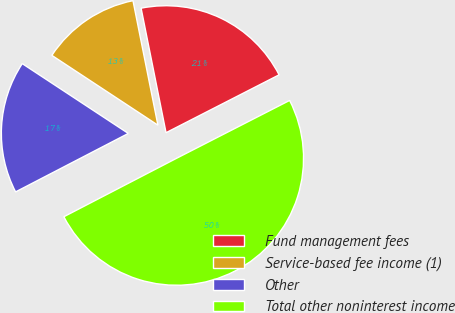Convert chart. <chart><loc_0><loc_0><loc_500><loc_500><pie_chart><fcel>Fund management fees<fcel>Service-based fee income (1)<fcel>Other<fcel>Total other noninterest income<nl><fcel>20.62%<fcel>12.59%<fcel>16.88%<fcel>49.92%<nl></chart> 